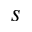<formula> <loc_0><loc_0><loc_500><loc_500>s</formula> 